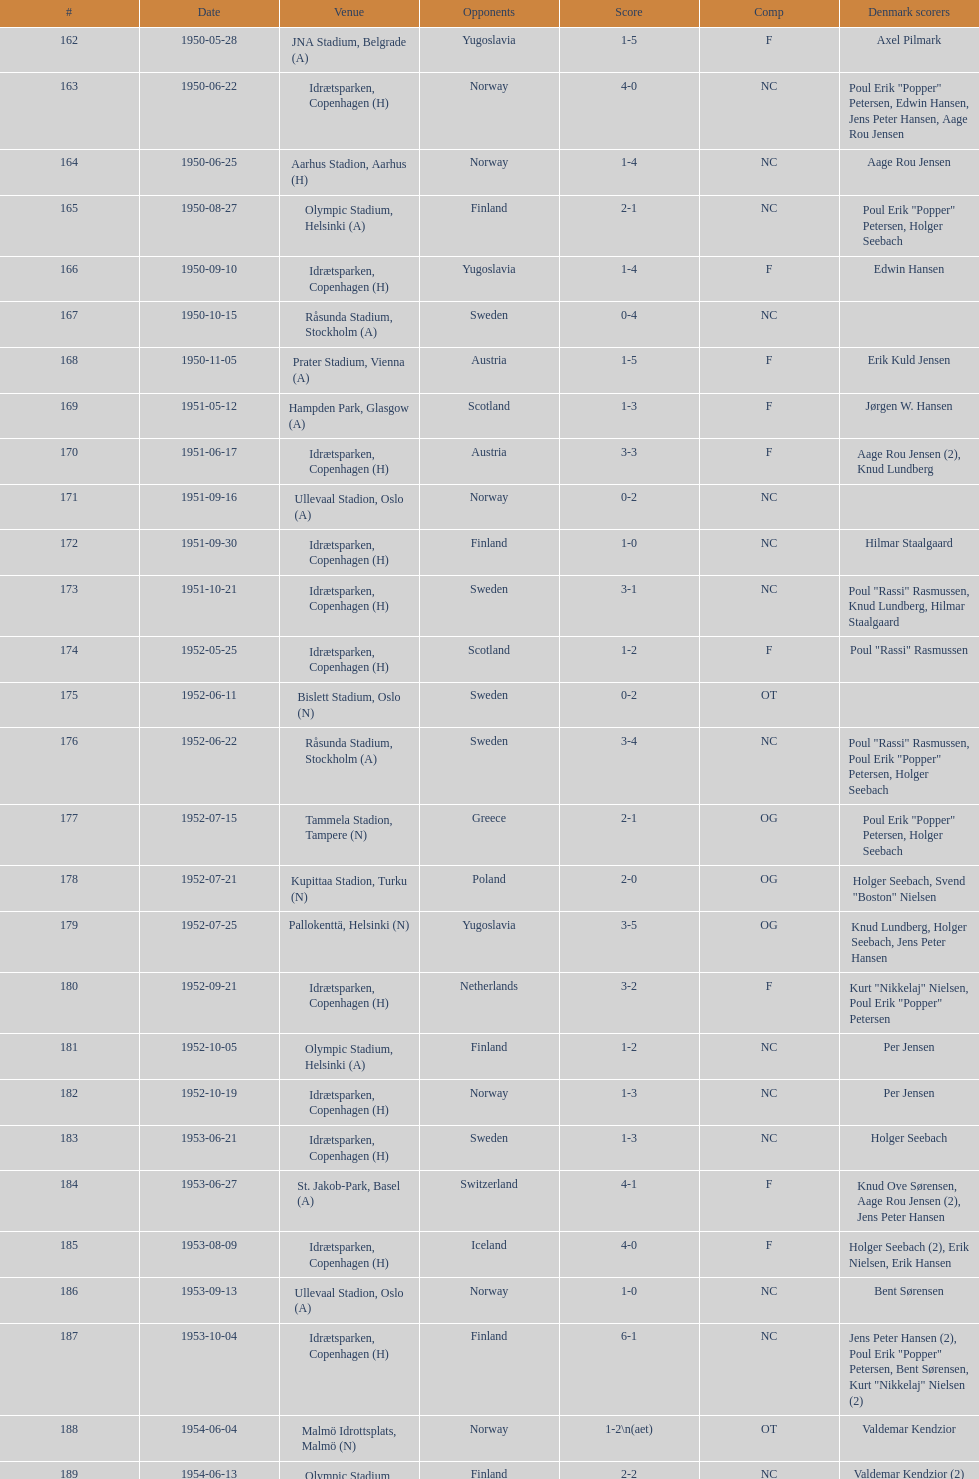Is denmark better against sweden or england? Sweden. 